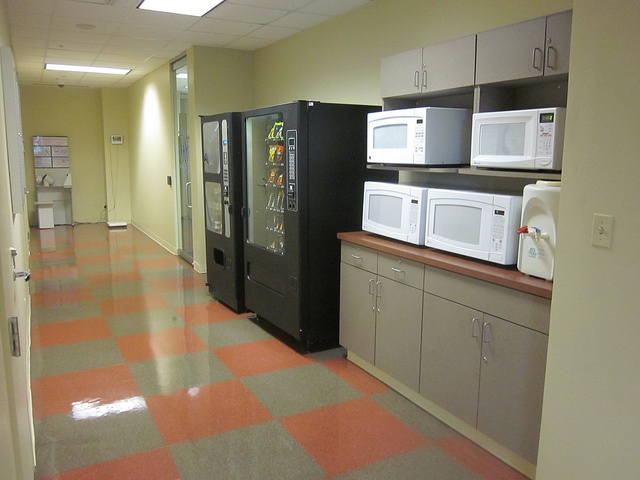Describe the objects in this image and their specific colors. I can see refrigerator in gray, black, darkgray, and darkgreen tones, refrigerator in gray, black, and darkgray tones, microwave in gray, lightgray, and darkgray tones, microwave in gray, white, and darkgray tones, and microwave in gray, lightgray, and darkgray tones in this image. 